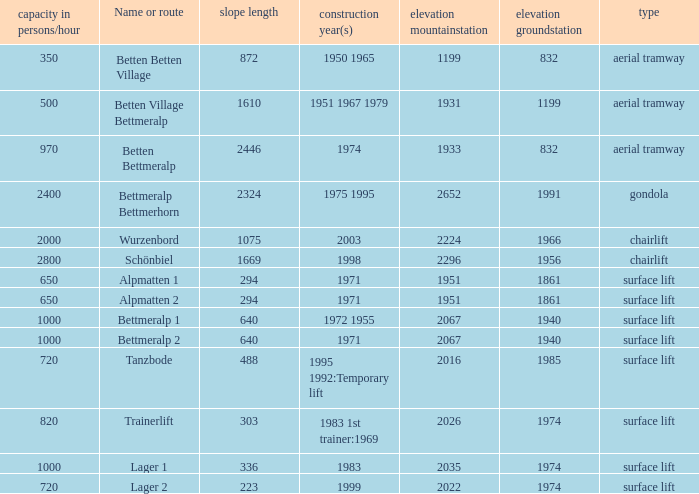Which slope length has a type of surface lift, and an elevation groundstation smaller than 1974, and a construction year(s) of 1971, and a Name or route of alpmatten 1? 294.0. 